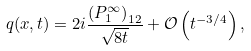Convert formula to latex. <formula><loc_0><loc_0><loc_500><loc_500>q ( x , t ) = 2 i \frac { \left ( P _ { 1 } ^ { \infty } \right ) _ { 1 2 } } { \sqrt { 8 t } } + \mathcal { O } \left ( t ^ { - 3 / 4 } \right ) ,</formula> 